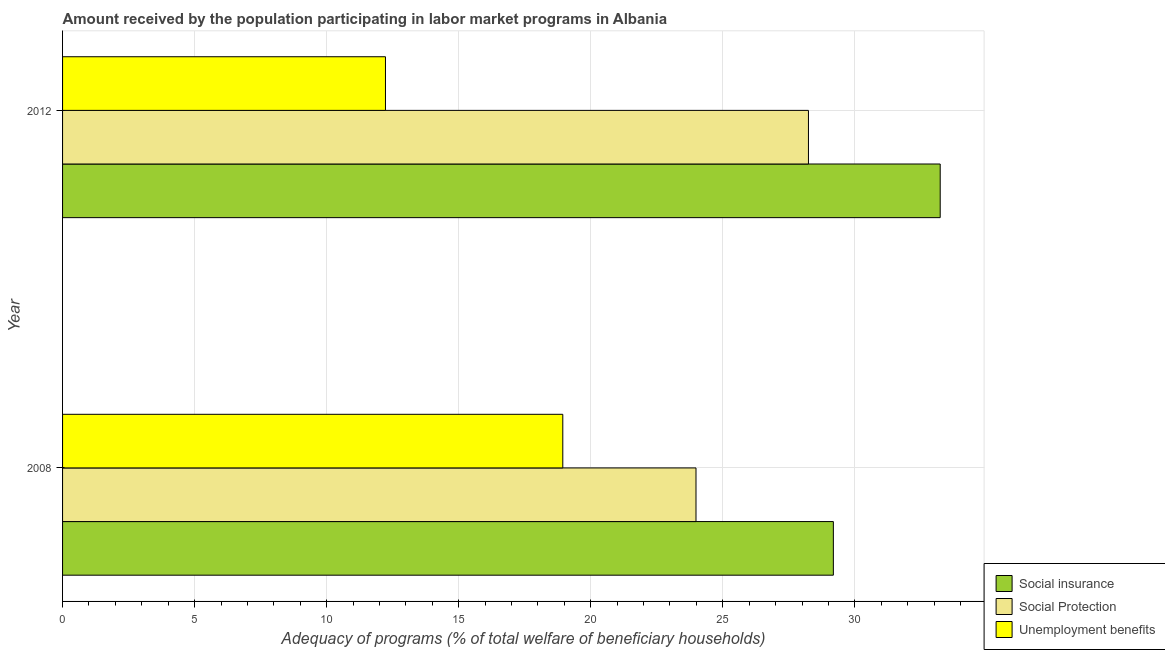How many groups of bars are there?
Make the answer very short. 2. Are the number of bars on each tick of the Y-axis equal?
Your answer should be very brief. Yes. What is the amount received by the population participating in social insurance programs in 2012?
Provide a short and direct response. 33.23. Across all years, what is the maximum amount received by the population participating in unemployment benefits programs?
Offer a terse response. 18.94. Across all years, what is the minimum amount received by the population participating in social protection programs?
Offer a very short reply. 23.99. In which year was the amount received by the population participating in social insurance programs maximum?
Offer a very short reply. 2012. What is the total amount received by the population participating in social insurance programs in the graph?
Give a very brief answer. 62.42. What is the difference between the amount received by the population participating in social insurance programs in 2008 and that in 2012?
Offer a terse response. -4.05. What is the difference between the amount received by the population participating in social insurance programs in 2008 and the amount received by the population participating in unemployment benefits programs in 2012?
Provide a short and direct response. 16.96. What is the average amount received by the population participating in social protection programs per year?
Provide a succinct answer. 26.11. In the year 2008, what is the difference between the amount received by the population participating in unemployment benefits programs and amount received by the population participating in social protection programs?
Your answer should be compact. -5.04. In how many years, is the amount received by the population participating in social insurance programs greater than 33 %?
Your response must be concise. 1. What is the ratio of the amount received by the population participating in social protection programs in 2008 to that in 2012?
Keep it short and to the point. 0.85. Is the amount received by the population participating in social insurance programs in 2008 less than that in 2012?
Offer a very short reply. Yes. What does the 1st bar from the top in 2012 represents?
Keep it short and to the point. Unemployment benefits. What does the 2nd bar from the bottom in 2012 represents?
Give a very brief answer. Social Protection. What is the difference between two consecutive major ticks on the X-axis?
Ensure brevity in your answer.  5. Does the graph contain any zero values?
Ensure brevity in your answer.  No. How many legend labels are there?
Offer a very short reply. 3. What is the title of the graph?
Your answer should be compact. Amount received by the population participating in labor market programs in Albania. Does "Social Protection and Labor" appear as one of the legend labels in the graph?
Provide a short and direct response. No. What is the label or title of the X-axis?
Offer a terse response. Adequacy of programs (% of total welfare of beneficiary households). What is the Adequacy of programs (% of total welfare of beneficiary households) in Social insurance in 2008?
Give a very brief answer. 29.19. What is the Adequacy of programs (% of total welfare of beneficiary households) of Social Protection in 2008?
Your answer should be very brief. 23.99. What is the Adequacy of programs (% of total welfare of beneficiary households) of Unemployment benefits in 2008?
Offer a very short reply. 18.94. What is the Adequacy of programs (% of total welfare of beneficiary households) in Social insurance in 2012?
Ensure brevity in your answer.  33.23. What is the Adequacy of programs (% of total welfare of beneficiary households) of Social Protection in 2012?
Your answer should be very brief. 28.24. What is the Adequacy of programs (% of total welfare of beneficiary households) of Unemployment benefits in 2012?
Keep it short and to the point. 12.23. Across all years, what is the maximum Adequacy of programs (% of total welfare of beneficiary households) in Social insurance?
Keep it short and to the point. 33.23. Across all years, what is the maximum Adequacy of programs (% of total welfare of beneficiary households) of Social Protection?
Offer a very short reply. 28.24. Across all years, what is the maximum Adequacy of programs (% of total welfare of beneficiary households) of Unemployment benefits?
Your answer should be compact. 18.94. Across all years, what is the minimum Adequacy of programs (% of total welfare of beneficiary households) in Social insurance?
Provide a short and direct response. 29.19. Across all years, what is the minimum Adequacy of programs (% of total welfare of beneficiary households) of Social Protection?
Make the answer very short. 23.99. Across all years, what is the minimum Adequacy of programs (% of total welfare of beneficiary households) in Unemployment benefits?
Give a very brief answer. 12.23. What is the total Adequacy of programs (% of total welfare of beneficiary households) of Social insurance in the graph?
Your response must be concise. 62.42. What is the total Adequacy of programs (% of total welfare of beneficiary households) in Social Protection in the graph?
Provide a succinct answer. 52.23. What is the total Adequacy of programs (% of total welfare of beneficiary households) of Unemployment benefits in the graph?
Your answer should be very brief. 31.17. What is the difference between the Adequacy of programs (% of total welfare of beneficiary households) of Social insurance in 2008 and that in 2012?
Offer a very short reply. -4.05. What is the difference between the Adequacy of programs (% of total welfare of beneficiary households) of Social Protection in 2008 and that in 2012?
Offer a terse response. -4.26. What is the difference between the Adequacy of programs (% of total welfare of beneficiary households) of Unemployment benefits in 2008 and that in 2012?
Offer a terse response. 6.71. What is the difference between the Adequacy of programs (% of total welfare of beneficiary households) in Social insurance in 2008 and the Adequacy of programs (% of total welfare of beneficiary households) in Social Protection in 2012?
Provide a succinct answer. 0.94. What is the difference between the Adequacy of programs (% of total welfare of beneficiary households) of Social insurance in 2008 and the Adequacy of programs (% of total welfare of beneficiary households) of Unemployment benefits in 2012?
Make the answer very short. 16.96. What is the difference between the Adequacy of programs (% of total welfare of beneficiary households) of Social Protection in 2008 and the Adequacy of programs (% of total welfare of beneficiary households) of Unemployment benefits in 2012?
Your response must be concise. 11.76. What is the average Adequacy of programs (% of total welfare of beneficiary households) of Social insurance per year?
Your answer should be compact. 31.21. What is the average Adequacy of programs (% of total welfare of beneficiary households) of Social Protection per year?
Provide a succinct answer. 26.11. What is the average Adequacy of programs (% of total welfare of beneficiary households) in Unemployment benefits per year?
Keep it short and to the point. 15.58. In the year 2008, what is the difference between the Adequacy of programs (% of total welfare of beneficiary households) of Social insurance and Adequacy of programs (% of total welfare of beneficiary households) of Social Protection?
Your answer should be compact. 5.2. In the year 2008, what is the difference between the Adequacy of programs (% of total welfare of beneficiary households) of Social insurance and Adequacy of programs (% of total welfare of beneficiary households) of Unemployment benefits?
Provide a succinct answer. 10.24. In the year 2008, what is the difference between the Adequacy of programs (% of total welfare of beneficiary households) of Social Protection and Adequacy of programs (% of total welfare of beneficiary households) of Unemployment benefits?
Your answer should be compact. 5.04. In the year 2012, what is the difference between the Adequacy of programs (% of total welfare of beneficiary households) in Social insurance and Adequacy of programs (% of total welfare of beneficiary households) in Social Protection?
Offer a terse response. 4.99. In the year 2012, what is the difference between the Adequacy of programs (% of total welfare of beneficiary households) of Social insurance and Adequacy of programs (% of total welfare of beneficiary households) of Unemployment benefits?
Ensure brevity in your answer.  21.01. In the year 2012, what is the difference between the Adequacy of programs (% of total welfare of beneficiary households) of Social Protection and Adequacy of programs (% of total welfare of beneficiary households) of Unemployment benefits?
Offer a terse response. 16.02. What is the ratio of the Adequacy of programs (% of total welfare of beneficiary households) in Social insurance in 2008 to that in 2012?
Your answer should be very brief. 0.88. What is the ratio of the Adequacy of programs (% of total welfare of beneficiary households) in Social Protection in 2008 to that in 2012?
Provide a short and direct response. 0.85. What is the ratio of the Adequacy of programs (% of total welfare of beneficiary households) in Unemployment benefits in 2008 to that in 2012?
Your answer should be compact. 1.55. What is the difference between the highest and the second highest Adequacy of programs (% of total welfare of beneficiary households) of Social insurance?
Offer a terse response. 4.05. What is the difference between the highest and the second highest Adequacy of programs (% of total welfare of beneficiary households) in Social Protection?
Offer a terse response. 4.26. What is the difference between the highest and the second highest Adequacy of programs (% of total welfare of beneficiary households) in Unemployment benefits?
Offer a very short reply. 6.71. What is the difference between the highest and the lowest Adequacy of programs (% of total welfare of beneficiary households) of Social insurance?
Offer a very short reply. 4.05. What is the difference between the highest and the lowest Adequacy of programs (% of total welfare of beneficiary households) of Social Protection?
Provide a short and direct response. 4.26. What is the difference between the highest and the lowest Adequacy of programs (% of total welfare of beneficiary households) in Unemployment benefits?
Offer a very short reply. 6.71. 